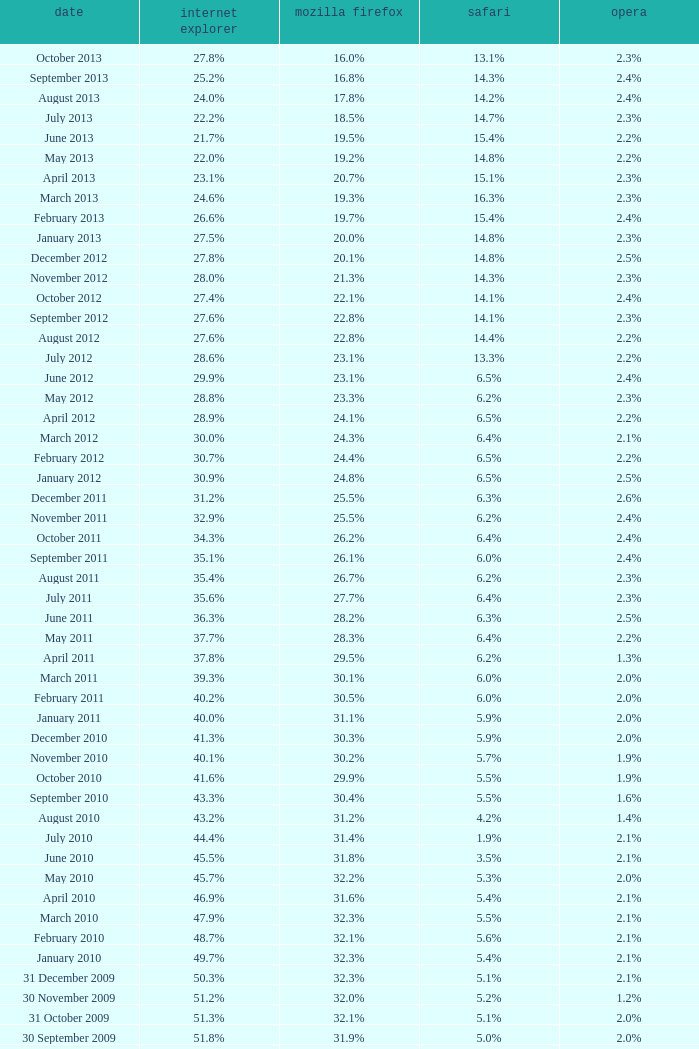What is the safari value with a 2.4% opera and 29.9% internet explorer? 6.5%. 